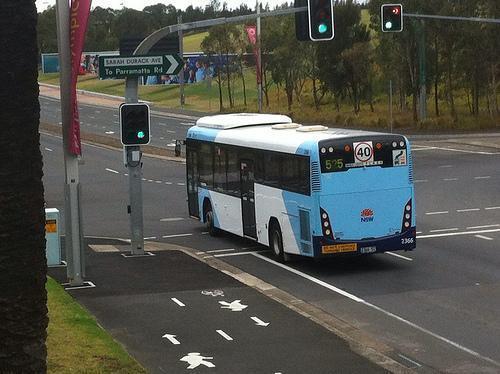How many busses are there?
Give a very brief answer. 1. 